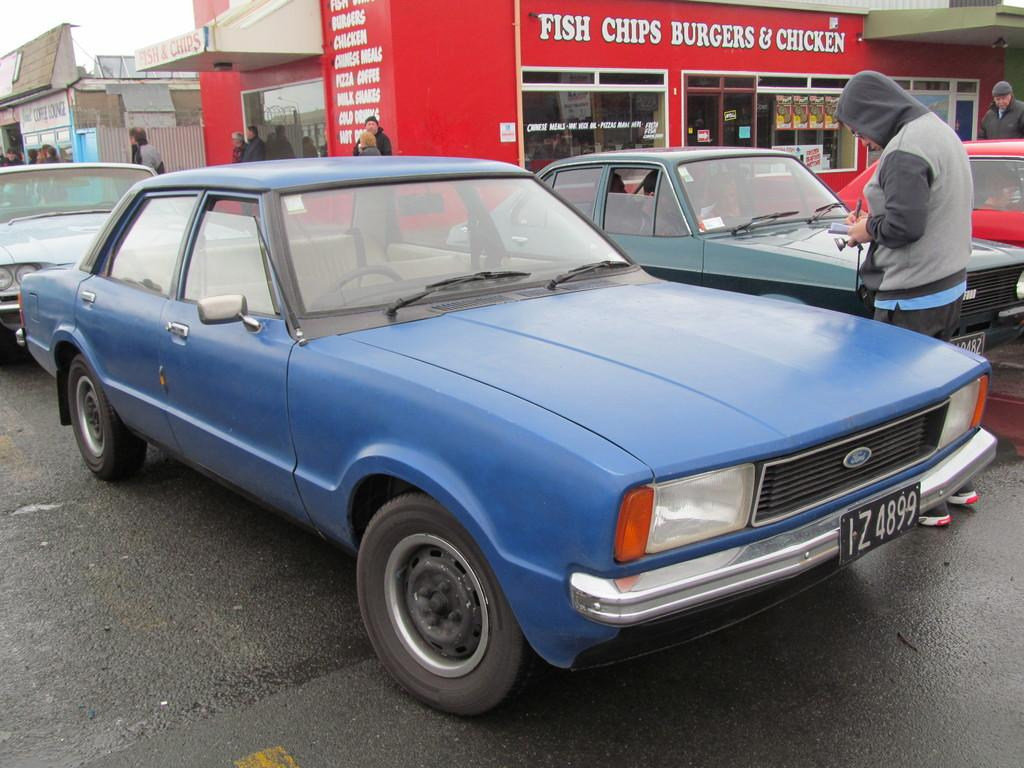<image>
Give a short and clear explanation of the subsequent image. A blue car in front of a place advertising Fish Chips Burgers and Chicken. 